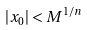<formula> <loc_0><loc_0><loc_500><loc_500>| x _ { 0 } | < M ^ { 1 / n }</formula> 